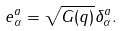Convert formula to latex. <formula><loc_0><loc_0><loc_500><loc_500>e ^ { a } _ { \alpha } = \sqrt { G ( q ) } \delta ^ { a } _ { \alpha } .</formula> 